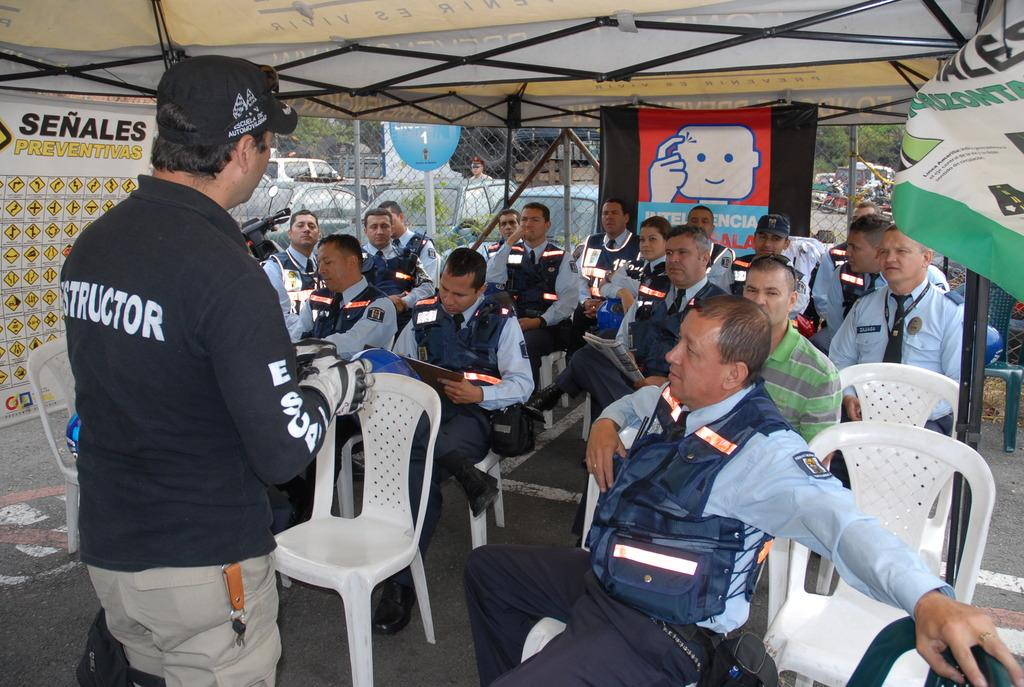What is the main setting of the image? The main setting of the image is under a tent. What are the people under the tent doing? The people are sitting under the tent. Is there anyone else interacting with the people under the tent? Yes, there is at least one man standing and talking to them. What type of bell can be heard ringing in the image? There is no bell present in the image, and therefore no sound can be heard. What is the profit margin of the people sitting under the tent in the image? There is no information about profit margins in the image, as it only shows people sitting under a tent and a man talking to them. 